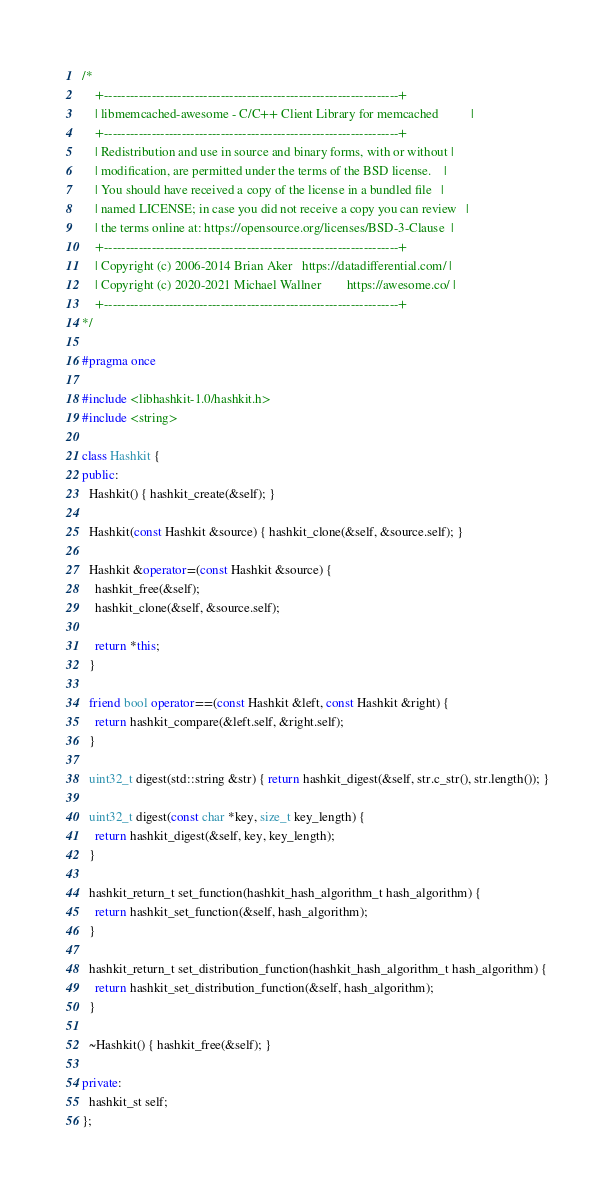<code> <loc_0><loc_0><loc_500><loc_500><_C++_>/*
    +--------------------------------------------------------------------+
    | libmemcached-awesome - C/C++ Client Library for memcached          |
    +--------------------------------------------------------------------+
    | Redistribution and use in source and binary forms, with or without |
    | modification, are permitted under the terms of the BSD license.    |
    | You should have received a copy of the license in a bundled file   |
    | named LICENSE; in case you did not receive a copy you can review   |
    | the terms online at: https://opensource.org/licenses/BSD-3-Clause  |
    +--------------------------------------------------------------------+
    | Copyright (c) 2006-2014 Brian Aker   https://datadifferential.com/ |
    | Copyright (c) 2020-2021 Michael Wallner        https://awesome.co/ |
    +--------------------------------------------------------------------+
*/

#pragma once

#include <libhashkit-1.0/hashkit.h>
#include <string>

class Hashkit {
public:
  Hashkit() { hashkit_create(&self); }

  Hashkit(const Hashkit &source) { hashkit_clone(&self, &source.self); }

  Hashkit &operator=(const Hashkit &source) {
    hashkit_free(&self);
    hashkit_clone(&self, &source.self);

    return *this;
  }

  friend bool operator==(const Hashkit &left, const Hashkit &right) {
    return hashkit_compare(&left.self, &right.self);
  }

  uint32_t digest(std::string &str) { return hashkit_digest(&self, str.c_str(), str.length()); }

  uint32_t digest(const char *key, size_t key_length) {
    return hashkit_digest(&self, key, key_length);
  }

  hashkit_return_t set_function(hashkit_hash_algorithm_t hash_algorithm) {
    return hashkit_set_function(&self, hash_algorithm);
  }

  hashkit_return_t set_distribution_function(hashkit_hash_algorithm_t hash_algorithm) {
    return hashkit_set_distribution_function(&self, hash_algorithm);
  }

  ~Hashkit() { hashkit_free(&self); }

private:
  hashkit_st self;
};
</code> 